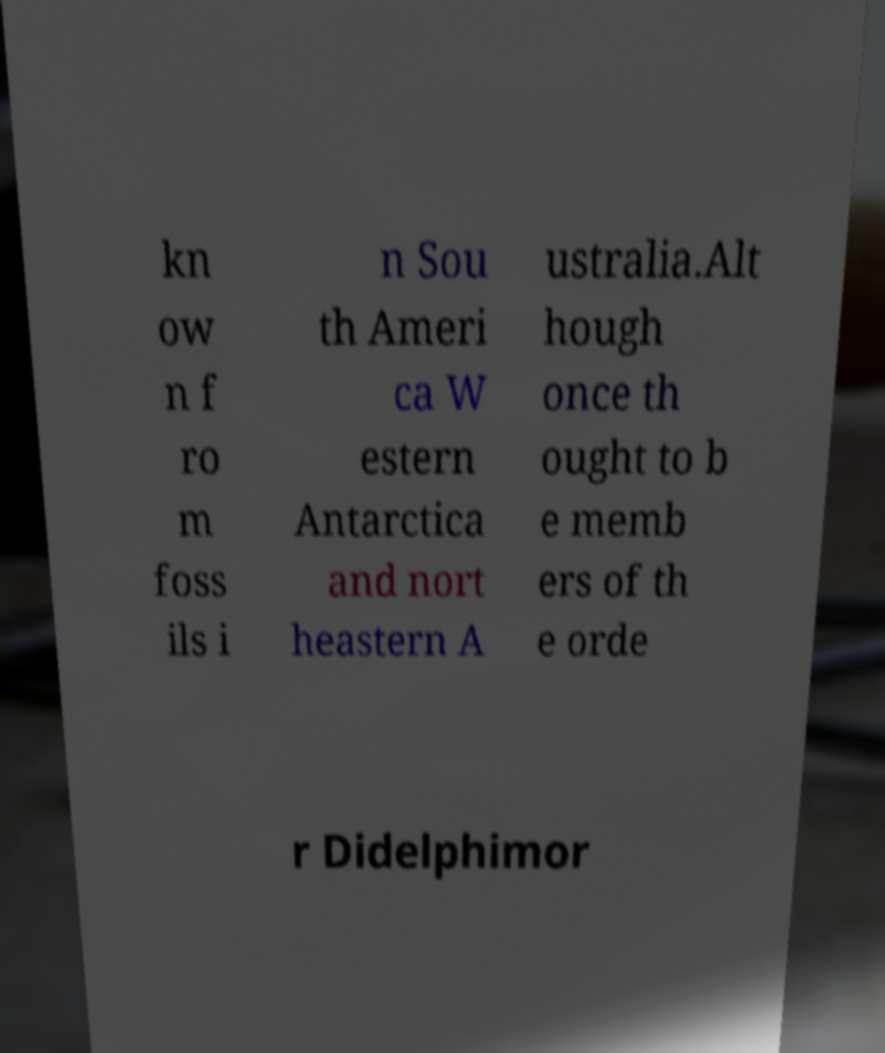Could you assist in decoding the text presented in this image and type it out clearly? kn ow n f ro m foss ils i n Sou th Ameri ca W estern Antarctica and nort heastern A ustralia.Alt hough once th ought to b e memb ers of th e orde r Didelphimor 